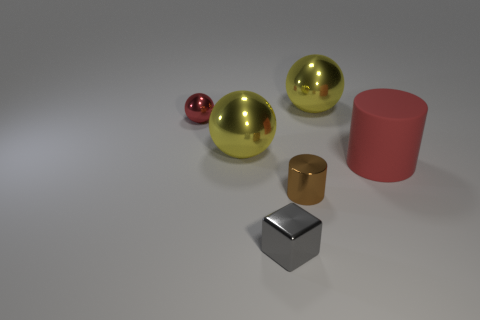Subtract all yellow balls. How many balls are left? 1 Subtract all blue cylinders. How many yellow balls are left? 2 Subtract all yellow spheres. How many spheres are left? 1 Add 3 small gray shiny objects. How many objects exist? 9 Subtract all cubes. How many objects are left? 5 Subtract 0 blue spheres. How many objects are left? 6 Subtract all blue cylinders. Subtract all cyan balls. How many cylinders are left? 2 Subtract all small gray metal things. Subtract all brown things. How many objects are left? 4 Add 5 yellow metal things. How many yellow metal things are left? 7 Add 4 large green matte cubes. How many large green matte cubes exist? 4 